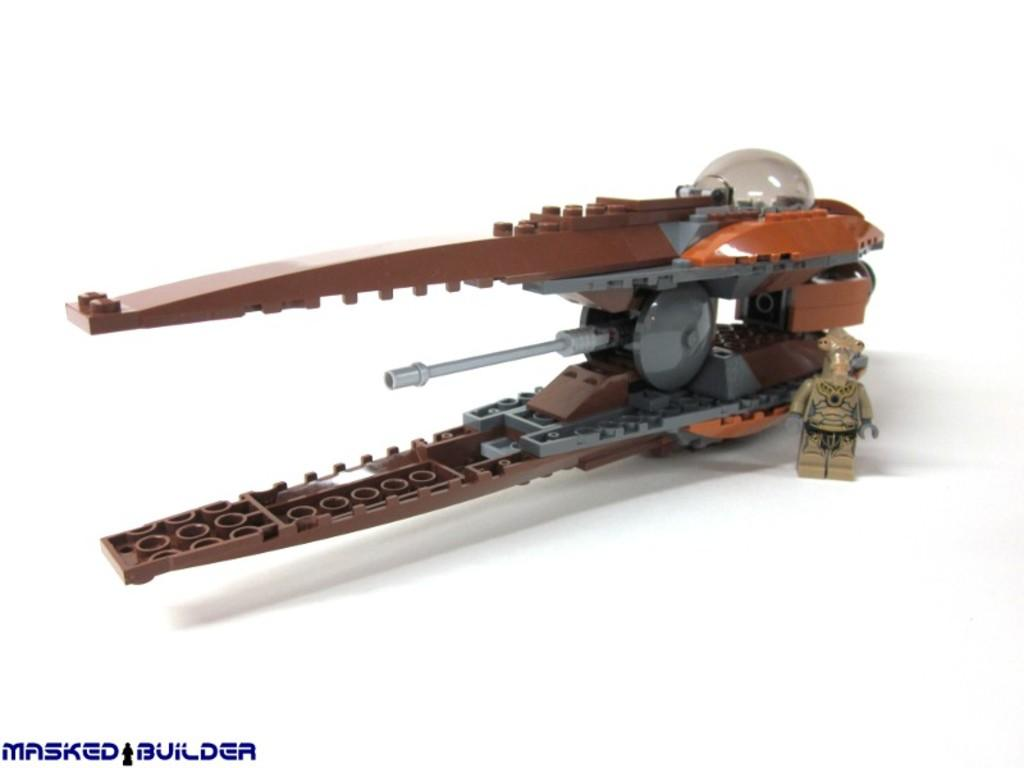What is the main subject of the image? The main subject of the image is a cutter made with Legos. Can you describe the cutter in more detail? The cutter is made entirely of Lego pieces, and it appears to be a functional tool. Where is the map located in the image? There is no map present in the image; it only features a cutter made with Legos. 